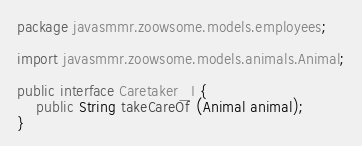<code> <loc_0><loc_0><loc_500><loc_500><_Java_>package javasmmr.zoowsome.models.employees;

import javasmmr.zoowsome.models.animals.Animal;

public interface Caretaker_I {
	public String takeCareOf (Animal animal);
}
</code> 